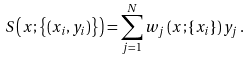<formula> <loc_0><loc_0><loc_500><loc_500>S \left ( x ; \left \{ ( x _ { i } , y _ { i } ) \right \} \right ) = \sum _ { j = 1 } ^ { N } w _ { j } \left ( x ; \{ x _ { i } \} \right ) y _ { j } \, .</formula> 